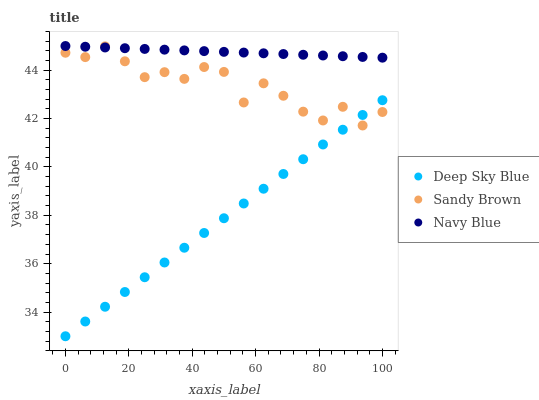Does Deep Sky Blue have the minimum area under the curve?
Answer yes or no. Yes. Does Navy Blue have the maximum area under the curve?
Answer yes or no. Yes. Does Sandy Brown have the minimum area under the curve?
Answer yes or no. No. Does Sandy Brown have the maximum area under the curve?
Answer yes or no. No. Is Navy Blue the smoothest?
Answer yes or no. Yes. Is Sandy Brown the roughest?
Answer yes or no. Yes. Is Deep Sky Blue the smoothest?
Answer yes or no. No. Is Deep Sky Blue the roughest?
Answer yes or no. No. Does Deep Sky Blue have the lowest value?
Answer yes or no. Yes. Does Sandy Brown have the lowest value?
Answer yes or no. No. Does Navy Blue have the highest value?
Answer yes or no. Yes. Does Sandy Brown have the highest value?
Answer yes or no. No. Is Deep Sky Blue less than Navy Blue?
Answer yes or no. Yes. Is Navy Blue greater than Deep Sky Blue?
Answer yes or no. Yes. Does Sandy Brown intersect Navy Blue?
Answer yes or no. Yes. Is Sandy Brown less than Navy Blue?
Answer yes or no. No. Is Sandy Brown greater than Navy Blue?
Answer yes or no. No. Does Deep Sky Blue intersect Navy Blue?
Answer yes or no. No. 